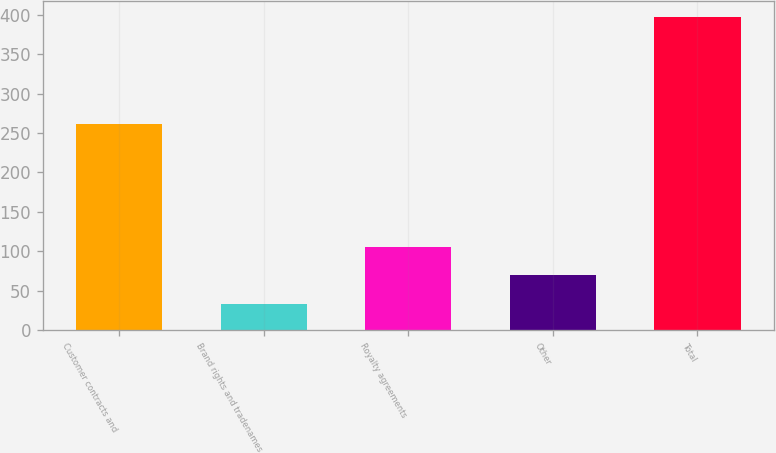Convert chart. <chart><loc_0><loc_0><loc_500><loc_500><bar_chart><fcel>Customer contracts and<fcel>Brand rights and tradenames<fcel>Royalty agreements<fcel>Other<fcel>Total<nl><fcel>261<fcel>33<fcel>105.8<fcel>69.4<fcel>397<nl></chart> 